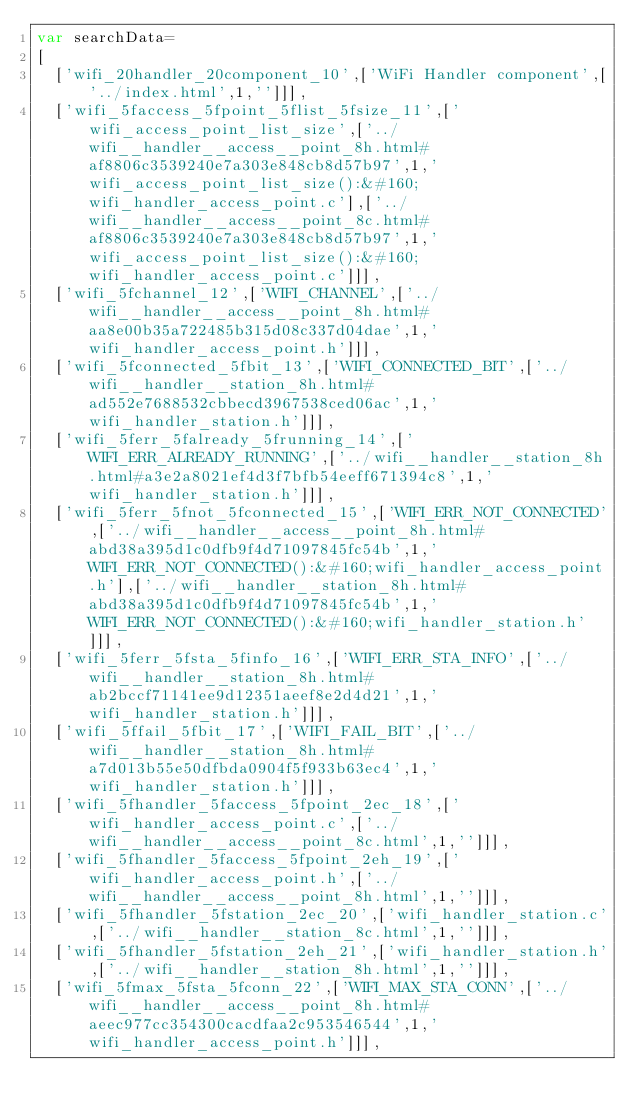Convert code to text. <code><loc_0><loc_0><loc_500><loc_500><_JavaScript_>var searchData=
[
  ['wifi_20handler_20component_10',['WiFi Handler component',['../index.html',1,'']]],
  ['wifi_5faccess_5fpoint_5flist_5fsize_11',['wifi_access_point_list_size',['../wifi__handler__access__point_8h.html#af8806c3539240e7a303e848cb8d57b97',1,'wifi_access_point_list_size():&#160;wifi_handler_access_point.c'],['../wifi__handler__access__point_8c.html#af8806c3539240e7a303e848cb8d57b97',1,'wifi_access_point_list_size():&#160;wifi_handler_access_point.c']]],
  ['wifi_5fchannel_12',['WIFI_CHANNEL',['../wifi__handler__access__point_8h.html#aa8e00b35a722485b315d08c337d04dae',1,'wifi_handler_access_point.h']]],
  ['wifi_5fconnected_5fbit_13',['WIFI_CONNECTED_BIT',['../wifi__handler__station_8h.html#ad552e7688532cbbecd3967538ced06ac',1,'wifi_handler_station.h']]],
  ['wifi_5ferr_5falready_5frunning_14',['WIFI_ERR_ALREADY_RUNNING',['../wifi__handler__station_8h.html#a3e2a8021ef4d3f7bfb54eeff671394c8',1,'wifi_handler_station.h']]],
  ['wifi_5ferr_5fnot_5fconnected_15',['WIFI_ERR_NOT_CONNECTED',['../wifi__handler__access__point_8h.html#abd38a395d1c0dfb9f4d71097845fc54b',1,'WIFI_ERR_NOT_CONNECTED():&#160;wifi_handler_access_point.h'],['../wifi__handler__station_8h.html#abd38a395d1c0dfb9f4d71097845fc54b',1,'WIFI_ERR_NOT_CONNECTED():&#160;wifi_handler_station.h']]],
  ['wifi_5ferr_5fsta_5finfo_16',['WIFI_ERR_STA_INFO',['../wifi__handler__station_8h.html#ab2bccf71141ee9d12351aeef8e2d4d21',1,'wifi_handler_station.h']]],
  ['wifi_5ffail_5fbit_17',['WIFI_FAIL_BIT',['../wifi__handler__station_8h.html#a7d013b55e50dfbda0904f5f933b63ec4',1,'wifi_handler_station.h']]],
  ['wifi_5fhandler_5faccess_5fpoint_2ec_18',['wifi_handler_access_point.c',['../wifi__handler__access__point_8c.html',1,'']]],
  ['wifi_5fhandler_5faccess_5fpoint_2eh_19',['wifi_handler_access_point.h',['../wifi__handler__access__point_8h.html',1,'']]],
  ['wifi_5fhandler_5fstation_2ec_20',['wifi_handler_station.c',['../wifi__handler__station_8c.html',1,'']]],
  ['wifi_5fhandler_5fstation_2eh_21',['wifi_handler_station.h',['../wifi__handler__station_8h.html',1,'']]],
  ['wifi_5fmax_5fsta_5fconn_22',['WIFI_MAX_STA_CONN',['../wifi__handler__access__point_8h.html#aeec977cc354300cacdfaa2c953546544',1,'wifi_handler_access_point.h']]],</code> 